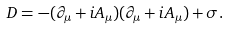<formula> <loc_0><loc_0><loc_500><loc_500>D = - ( \partial _ { \mu } + i A _ { \mu } ) ( \partial _ { \mu } + i A _ { \mu } ) + \sigma .</formula> 